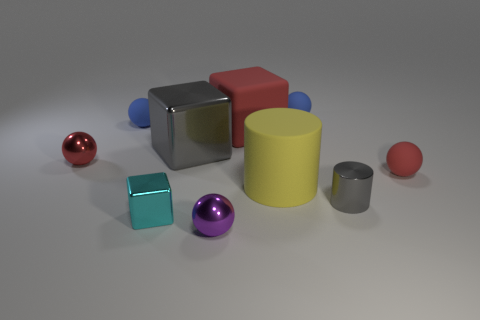Subtract all red matte spheres. How many spheres are left? 4 Subtract 2 balls. How many balls are left? 3 Subtract all cyan balls. Subtract all green blocks. How many balls are left? 5 Subtract all cubes. How many objects are left? 7 Subtract all gray metal objects. Subtract all big brown matte things. How many objects are left? 8 Add 5 tiny gray cylinders. How many tiny gray cylinders are left? 6 Add 5 tiny rubber cylinders. How many tiny rubber cylinders exist? 5 Subtract 0 brown blocks. How many objects are left? 10 